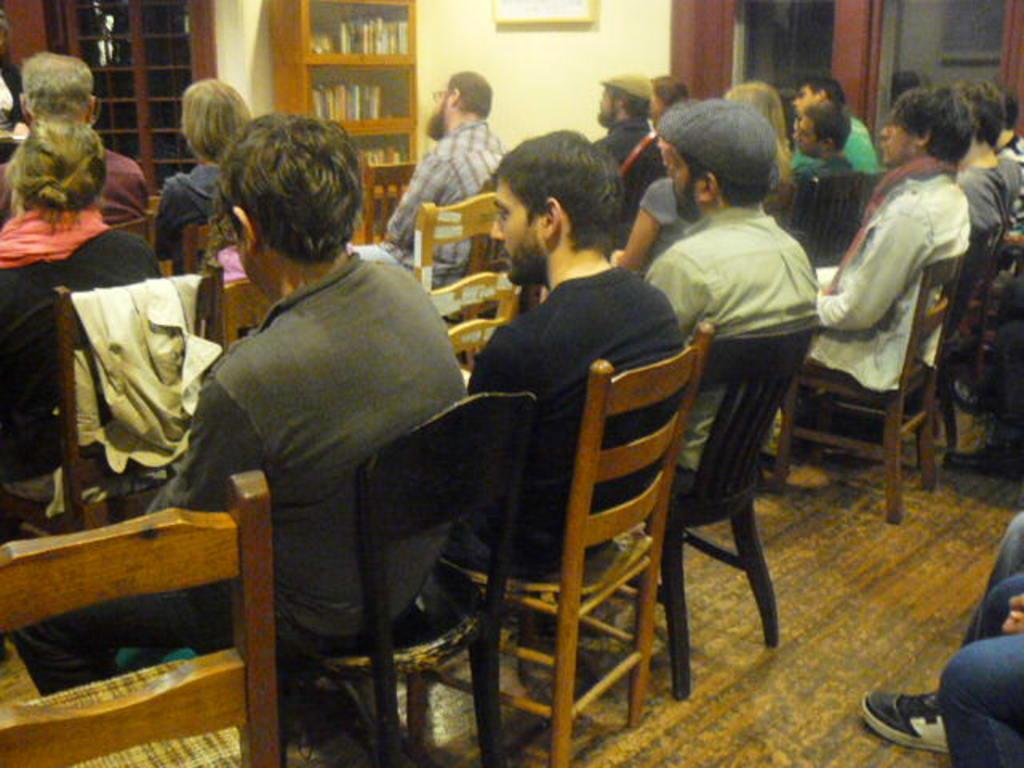What can be seen on the wall in the background of the image? There is a frame on a wall in the background. What architectural feature is present in the image? There is a door in the image. Where are the books located in the image? Books are arranged in a cupboard. What are the people in the image doing? There are persons sitting on chairs. What part of the room is visible in the image? The floor is visible in the image. Can you see any bananas hanging from the ceiling in the image? There are no bananas visible in the image. Do the persons sitting on chairs have wings? The persons sitting on chairs do not have wings; they are human beings. 